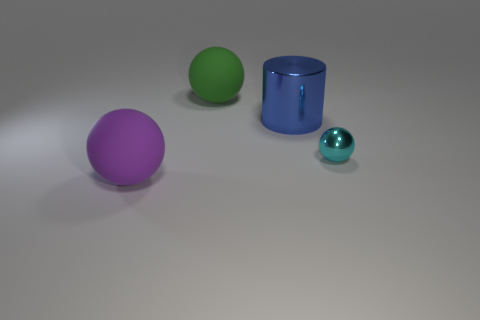Add 4 small cyan metal things. How many objects exist? 8 Subtract all spheres. How many objects are left? 1 Add 1 blue shiny cylinders. How many blue shiny cylinders exist? 2 Subtract 0 blue spheres. How many objects are left? 4 Subtract all cyan metallic cylinders. Subtract all big shiny objects. How many objects are left? 3 Add 2 green matte spheres. How many green matte spheres are left? 3 